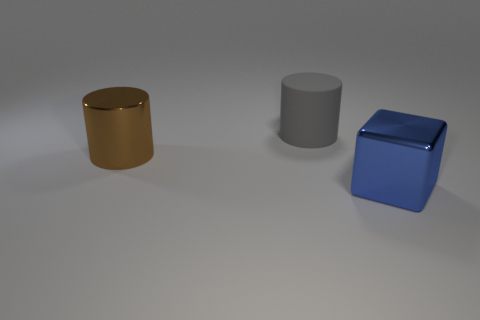Is there anything else that has the same material as the gray cylinder?
Offer a very short reply. No. Does the large metal object that is to the left of the big gray cylinder have the same shape as the object behind the big brown cylinder?
Make the answer very short. Yes. How many other objects are the same material as the large blue object?
Keep it short and to the point. 1. What is the material of the large gray cylinder?
Give a very brief answer. Rubber. What shape is the metallic thing to the right of the large object that is left of the rubber object?
Provide a succinct answer. Cube. There is a shiny thing behind the blue cube; what is its shape?
Your response must be concise. Cylinder. The block is what color?
Your answer should be compact. Blue. What number of matte cylinders are in front of the object that is left of the large matte object?
Offer a very short reply. 0. Does the matte cylinder have the same size as the brown cylinder?
Offer a terse response. Yes. Are there any shiny cylinders of the same size as the blue object?
Provide a short and direct response. Yes. 